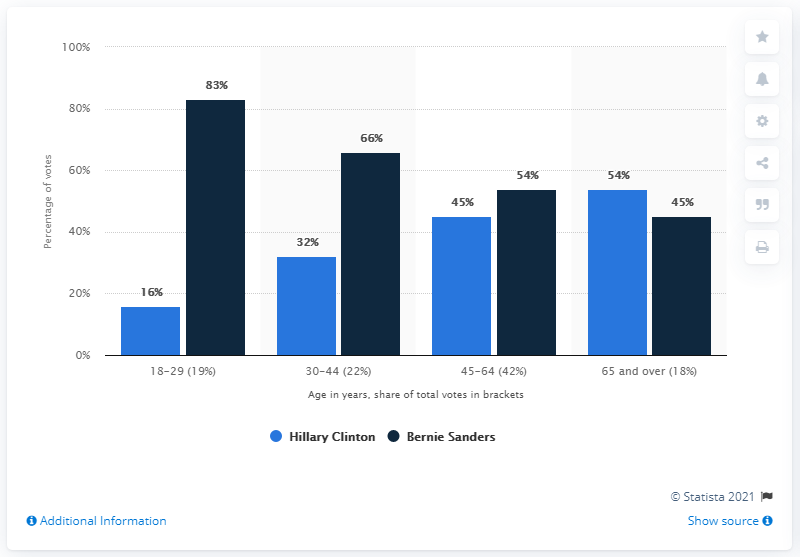Indicate a few pertinent items in this graphic. Bernie Sanders was the candidate who received a significant proportion of the votes from 18-29 year olds. 